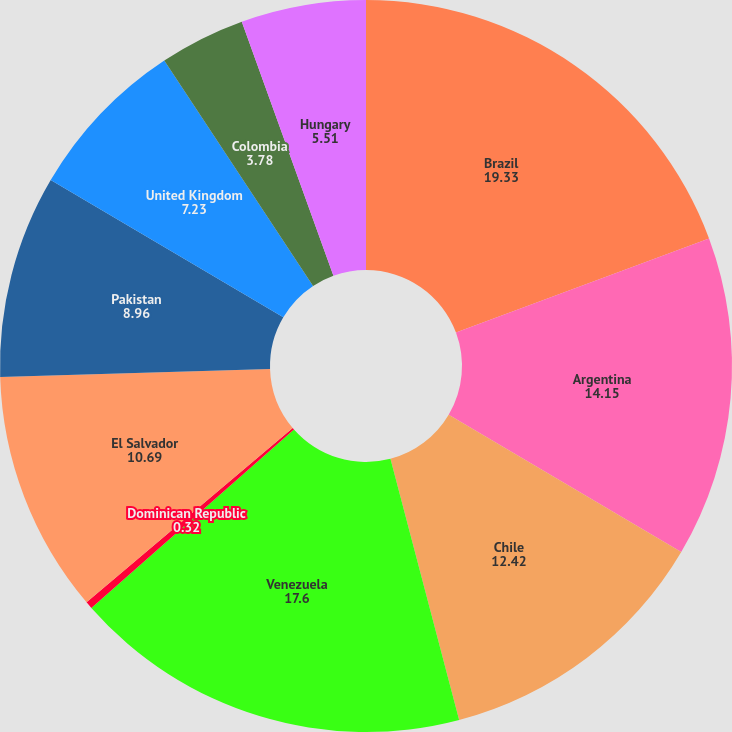Convert chart. <chart><loc_0><loc_0><loc_500><loc_500><pie_chart><fcel>Brazil<fcel>Argentina<fcel>Chile<fcel>Venezuela<fcel>Dominican Republic<fcel>El Salvador<fcel>Pakistan<fcel>United Kingdom<fcel>Colombia<fcel>Hungary<nl><fcel>19.33%<fcel>14.15%<fcel>12.42%<fcel>17.6%<fcel>0.32%<fcel>10.69%<fcel>8.96%<fcel>7.23%<fcel>3.78%<fcel>5.51%<nl></chart> 